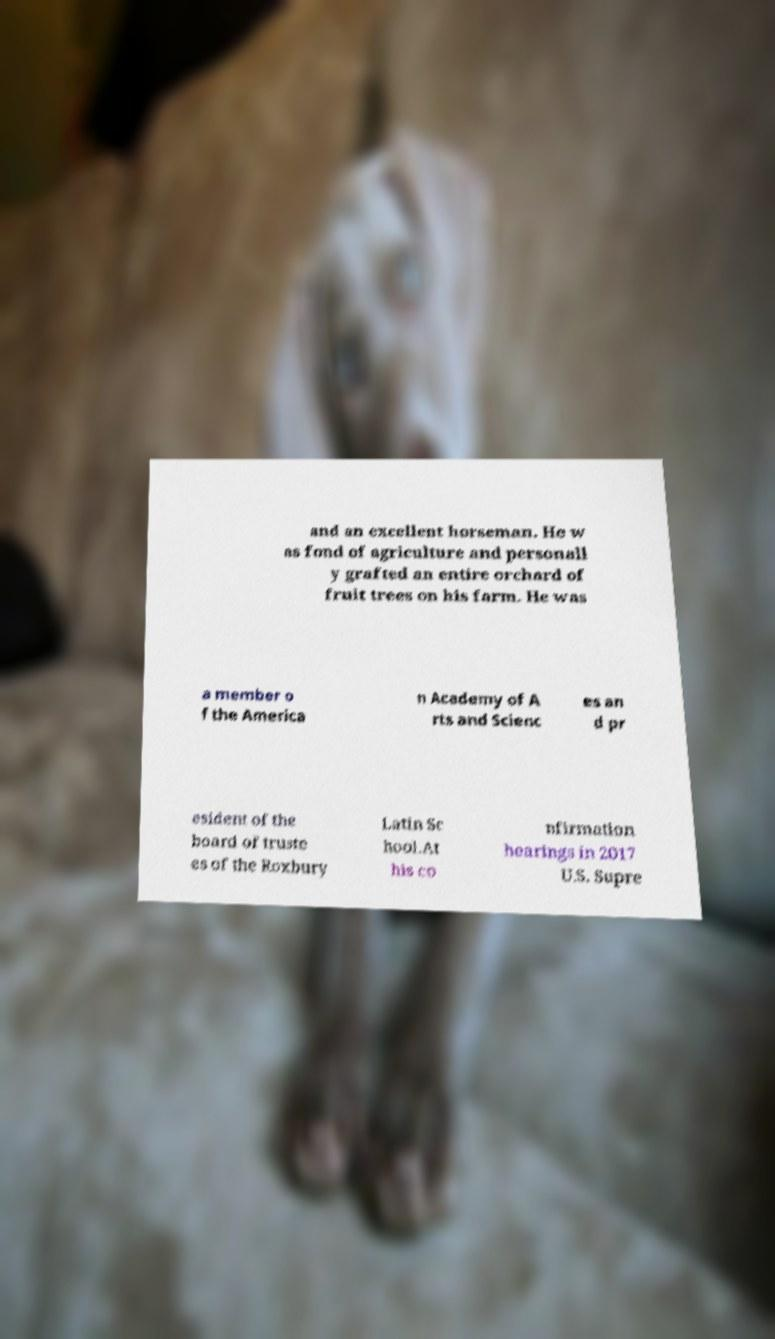I need the written content from this picture converted into text. Can you do that? and an excellent horseman. He w as fond of agriculture and personall y grafted an entire orchard of fruit trees on his farm. He was a member o f the America n Academy of A rts and Scienc es an d pr esident of the board of truste es of the Roxbury Latin Sc hool.At his co nfirmation hearings in 2017 U.S. Supre 